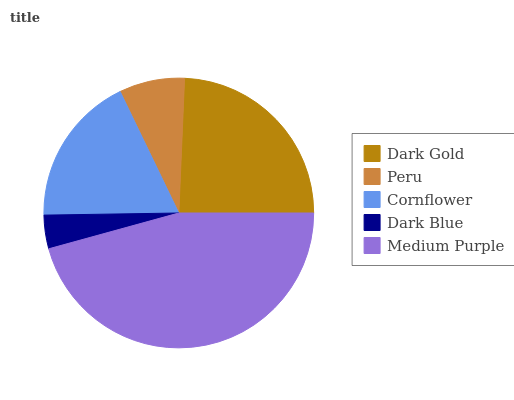Is Dark Blue the minimum?
Answer yes or no. Yes. Is Medium Purple the maximum?
Answer yes or no. Yes. Is Peru the minimum?
Answer yes or no. No. Is Peru the maximum?
Answer yes or no. No. Is Dark Gold greater than Peru?
Answer yes or no. Yes. Is Peru less than Dark Gold?
Answer yes or no. Yes. Is Peru greater than Dark Gold?
Answer yes or no. No. Is Dark Gold less than Peru?
Answer yes or no. No. Is Cornflower the high median?
Answer yes or no. Yes. Is Cornflower the low median?
Answer yes or no. Yes. Is Dark Gold the high median?
Answer yes or no. No. Is Medium Purple the low median?
Answer yes or no. No. 